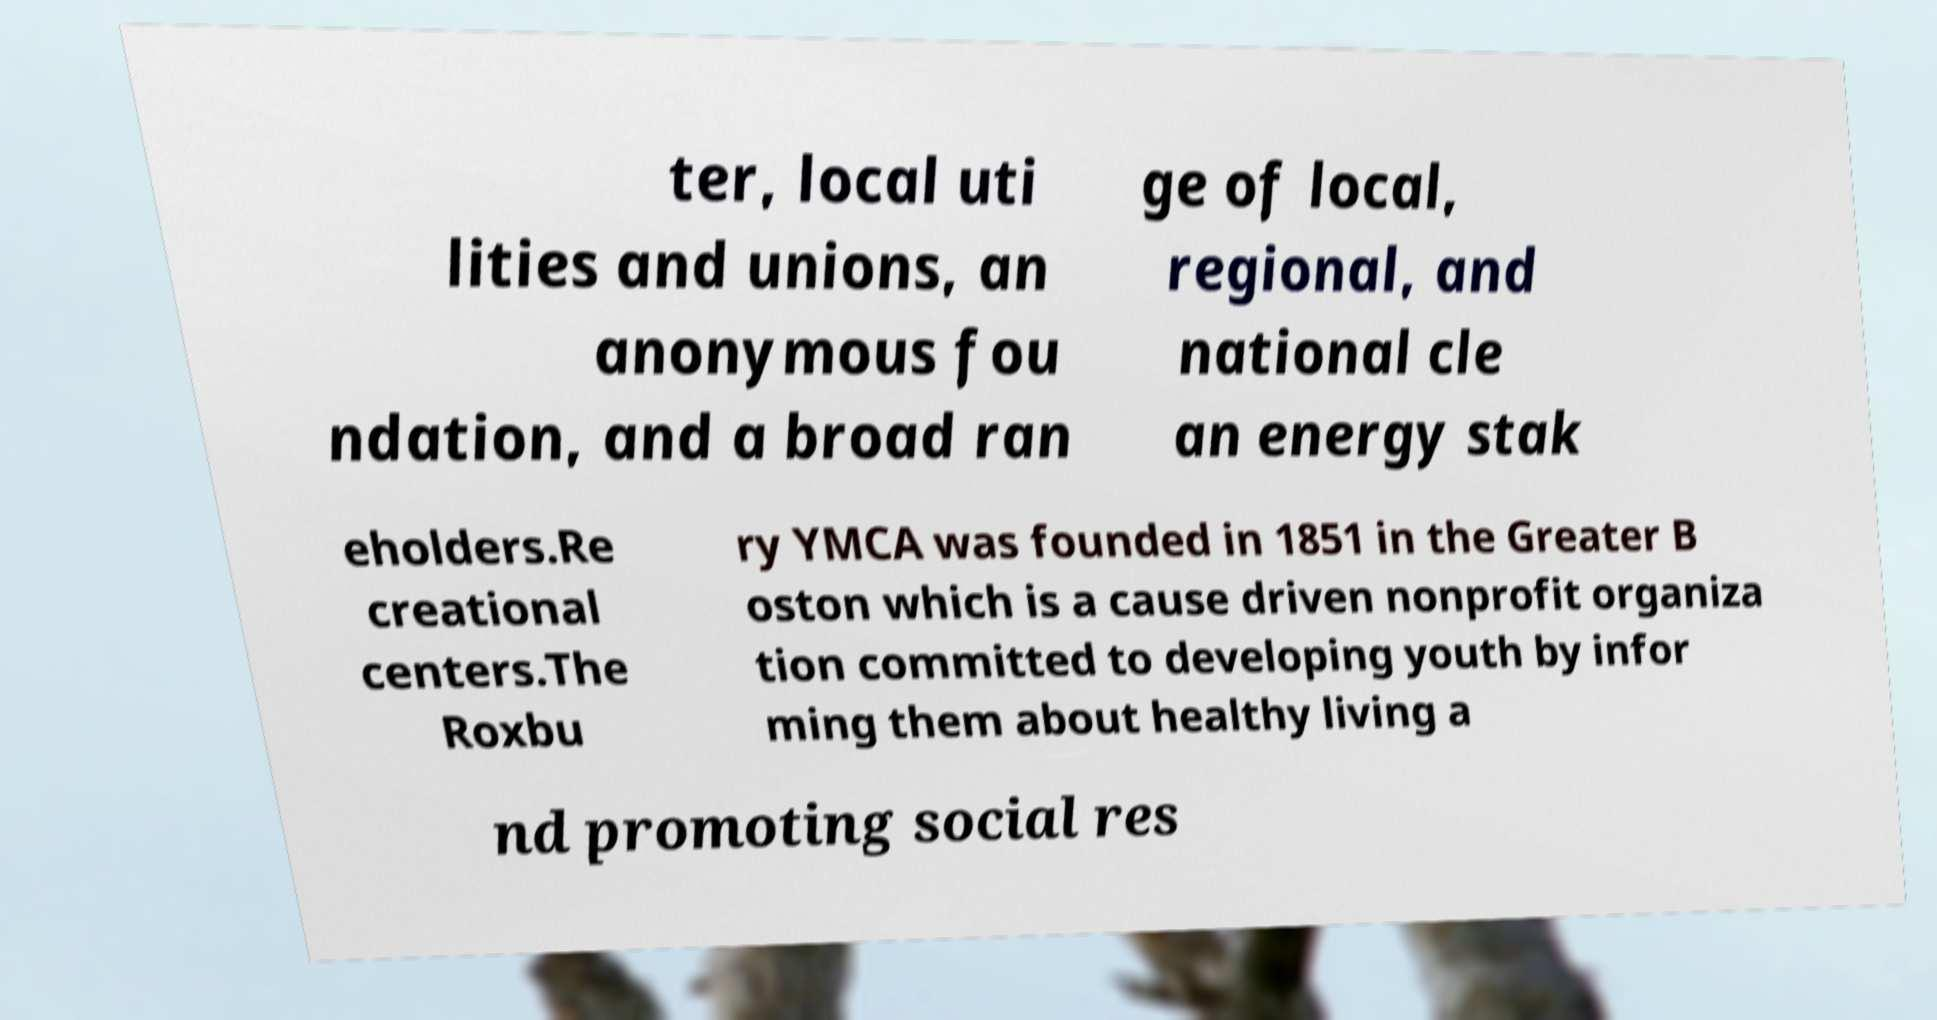Please read and relay the text visible in this image. What does it say? ter, local uti lities and unions, an anonymous fou ndation, and a broad ran ge of local, regional, and national cle an energy stak eholders.Re creational centers.The Roxbu ry YMCA was founded in 1851 in the Greater B oston which is a cause driven nonprofit organiza tion committed to developing youth by infor ming them about healthy living a nd promoting social res 